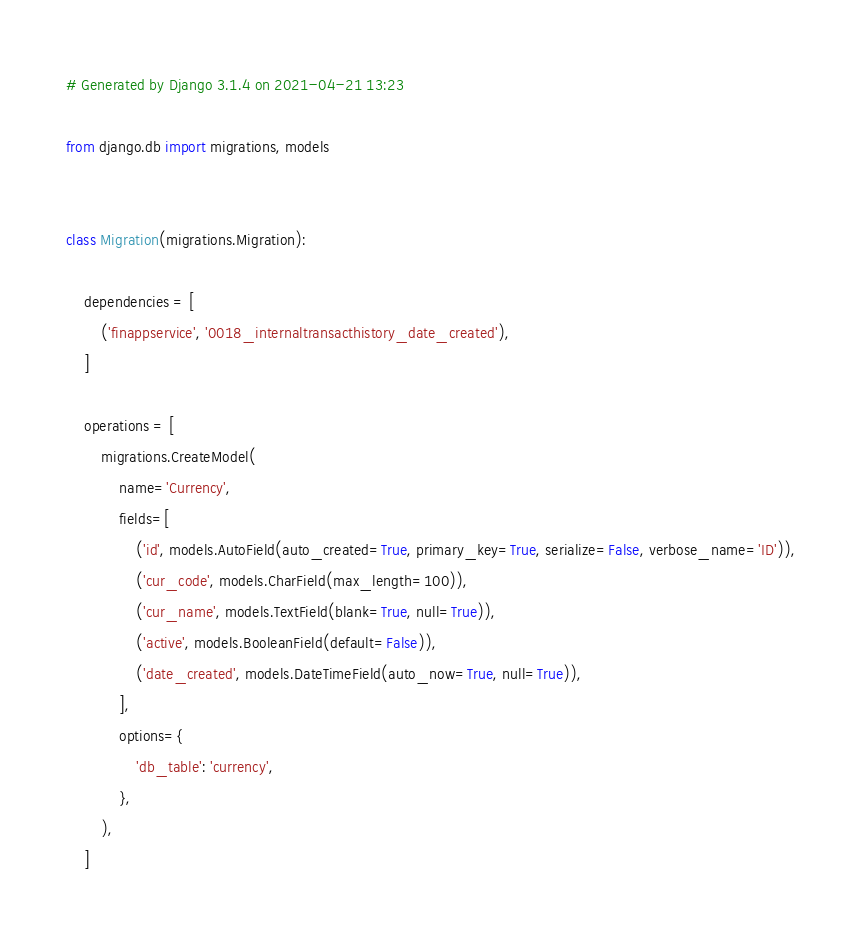<code> <loc_0><loc_0><loc_500><loc_500><_Python_># Generated by Django 3.1.4 on 2021-04-21 13:23

from django.db import migrations, models


class Migration(migrations.Migration):

    dependencies = [
        ('finappservice', '0018_internaltransacthistory_date_created'),
    ]

    operations = [
        migrations.CreateModel(
            name='Currency',
            fields=[
                ('id', models.AutoField(auto_created=True, primary_key=True, serialize=False, verbose_name='ID')),
                ('cur_code', models.CharField(max_length=100)),
                ('cur_name', models.TextField(blank=True, null=True)),
                ('active', models.BooleanField(default=False)),
                ('date_created', models.DateTimeField(auto_now=True, null=True)),
            ],
            options={
                'db_table': 'currency',
            },
        ),
    ]
</code> 